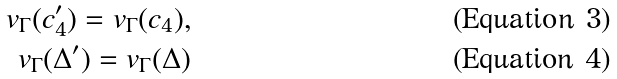<formula> <loc_0><loc_0><loc_500><loc_500>v _ { \Gamma } ( c ^ { \prime } _ { 4 } ) = v _ { \Gamma } ( c _ { 4 } ) , \\ v _ { \Gamma } ( \Delta ^ { \prime } ) = v _ { \Gamma } ( \Delta )</formula> 